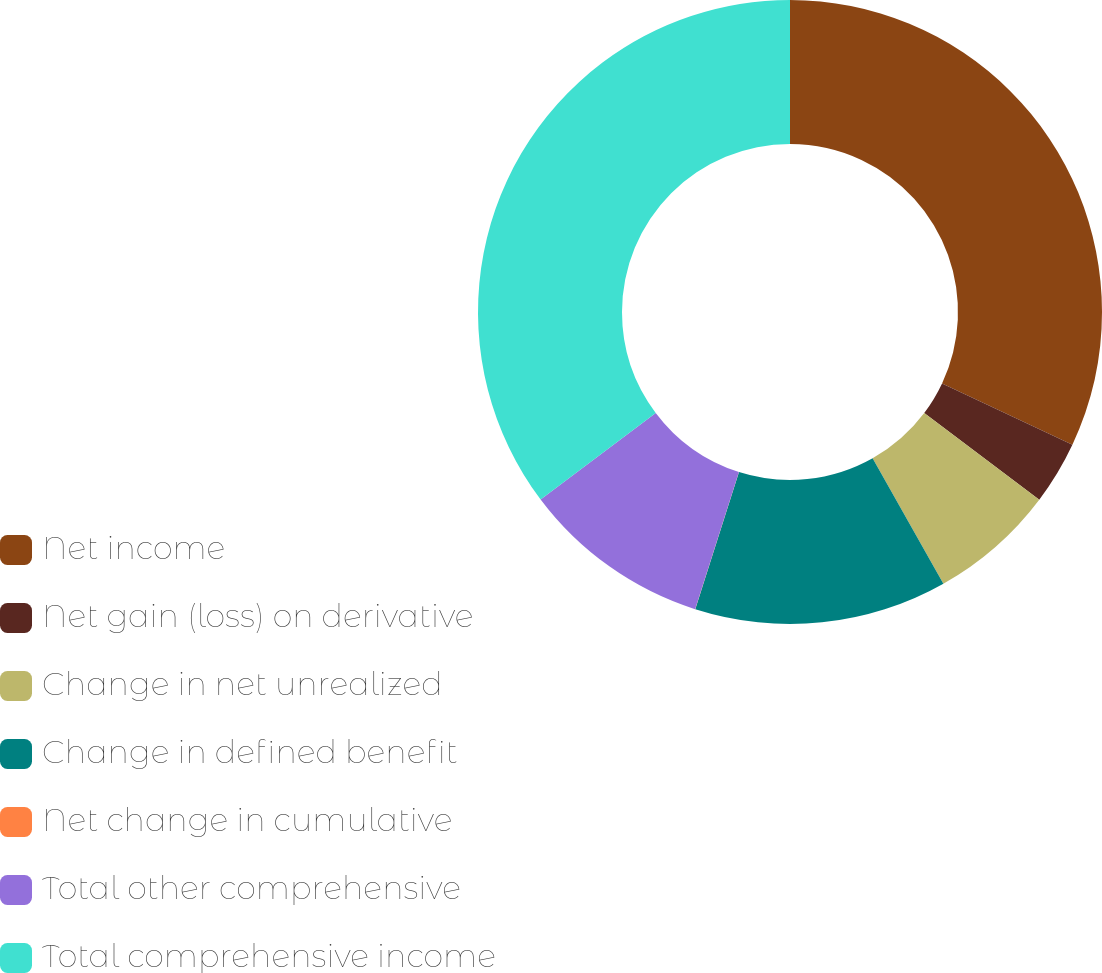<chart> <loc_0><loc_0><loc_500><loc_500><pie_chart><fcel>Net income<fcel>Net gain (loss) on derivative<fcel>Change in net unrealized<fcel>Change in defined benefit<fcel>Net change in cumulative<fcel>Total other comprehensive<fcel>Total comprehensive income<nl><fcel>31.99%<fcel>3.28%<fcel>6.55%<fcel>13.09%<fcel>0.01%<fcel>9.82%<fcel>35.26%<nl></chart> 